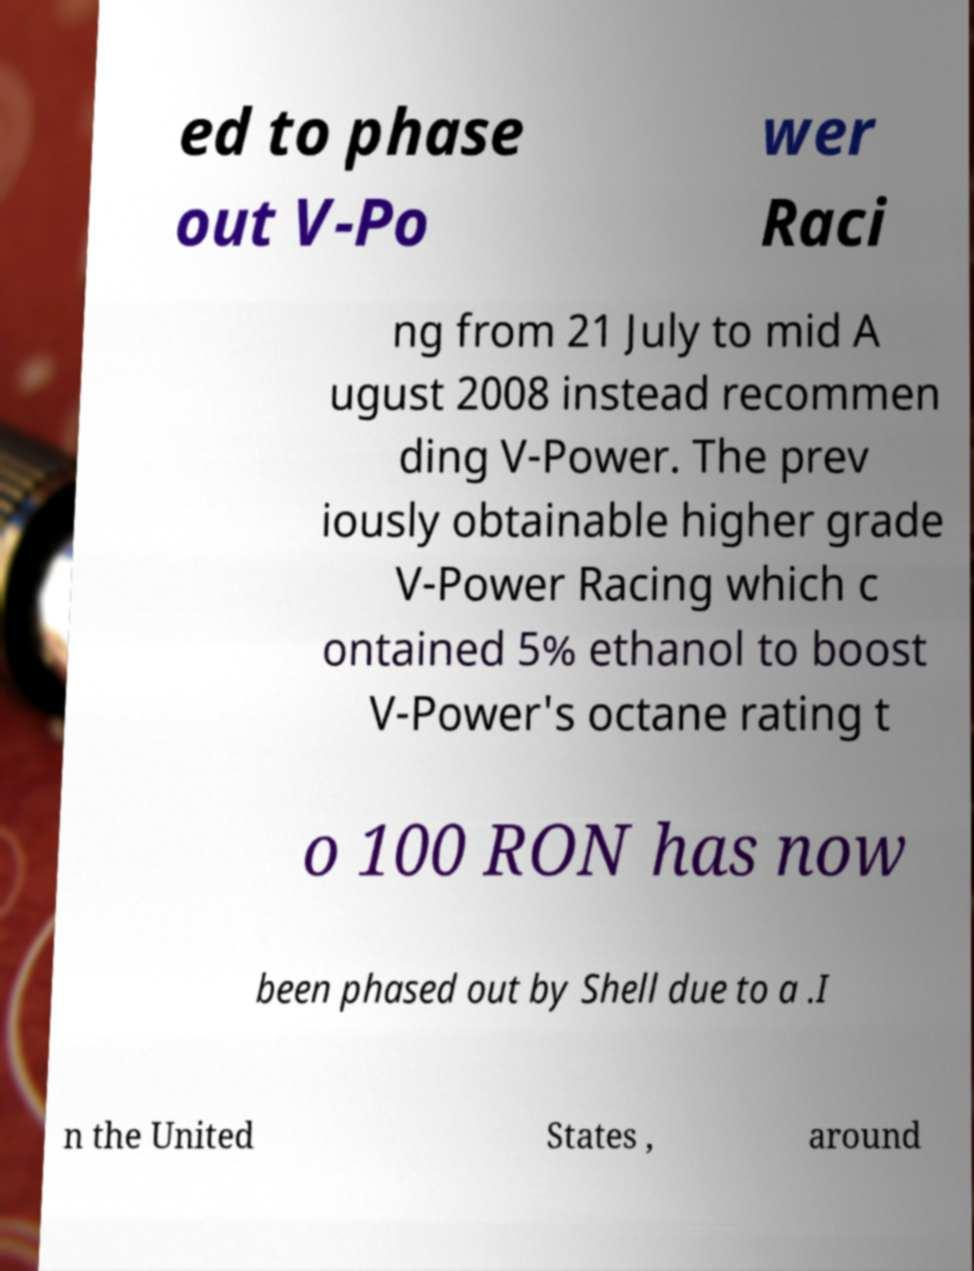For documentation purposes, I need the text within this image transcribed. Could you provide that? ed to phase out V-Po wer Raci ng from 21 July to mid A ugust 2008 instead recommen ding V-Power. The prev iously obtainable higher grade V-Power Racing which c ontained 5% ethanol to boost V-Power's octane rating t o 100 RON has now been phased out by Shell due to a .I n the United States , around 